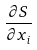Convert formula to latex. <formula><loc_0><loc_0><loc_500><loc_500>\frac { \partial S } { \partial x _ { i } }</formula> 